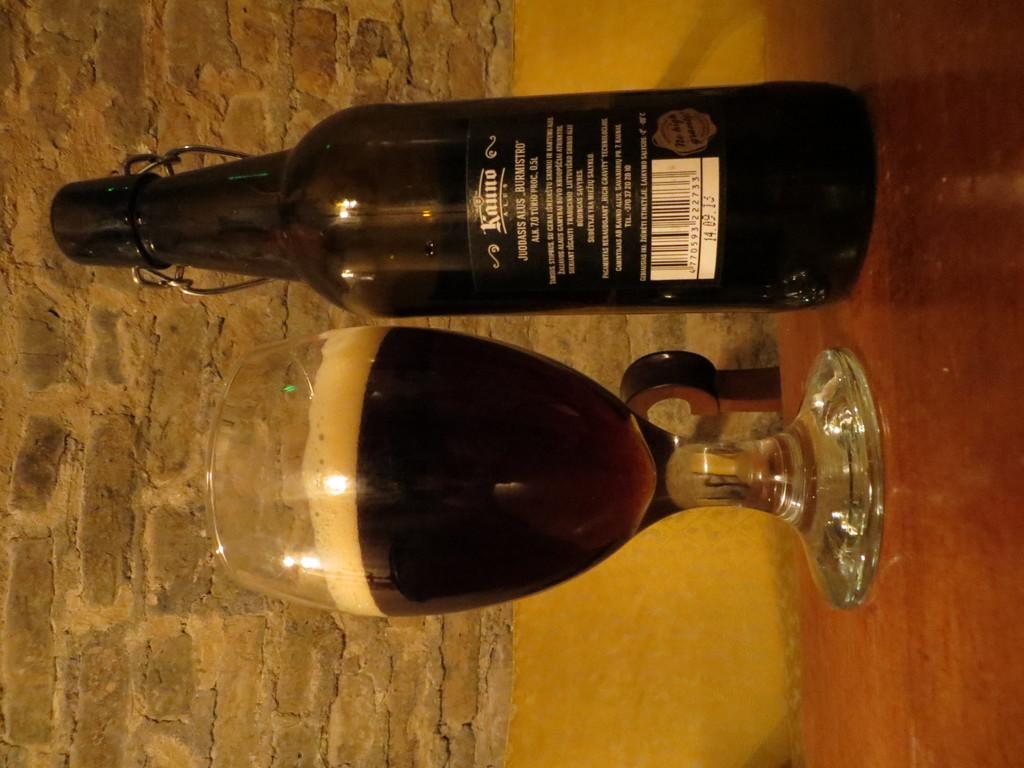<image>
Share a concise interpretation of the image provided. A bottle of Kunuo beer next to an almost full glass. 